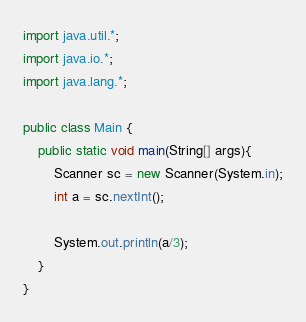<code> <loc_0><loc_0><loc_500><loc_500><_Java_>import java.util.*;
import java.io.*;
import java.lang.*;

public class Main {
    public static void main(String[] args){
        Scanner sc = new Scanner(System.in);
        int a = sc.nextInt();
        
        System.out.println(a/3);
    }
}
</code> 